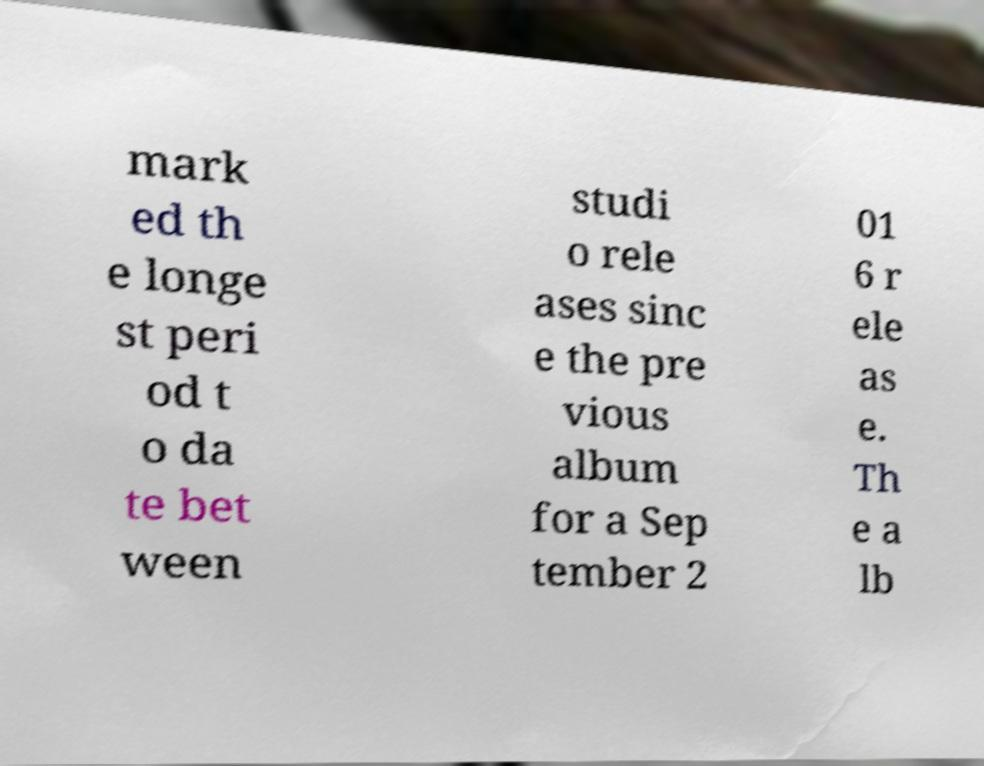For documentation purposes, I need the text within this image transcribed. Could you provide that? mark ed th e longe st peri od t o da te bet ween studi o rele ases sinc e the pre vious album for a Sep tember 2 01 6 r ele as e. Th e a lb 